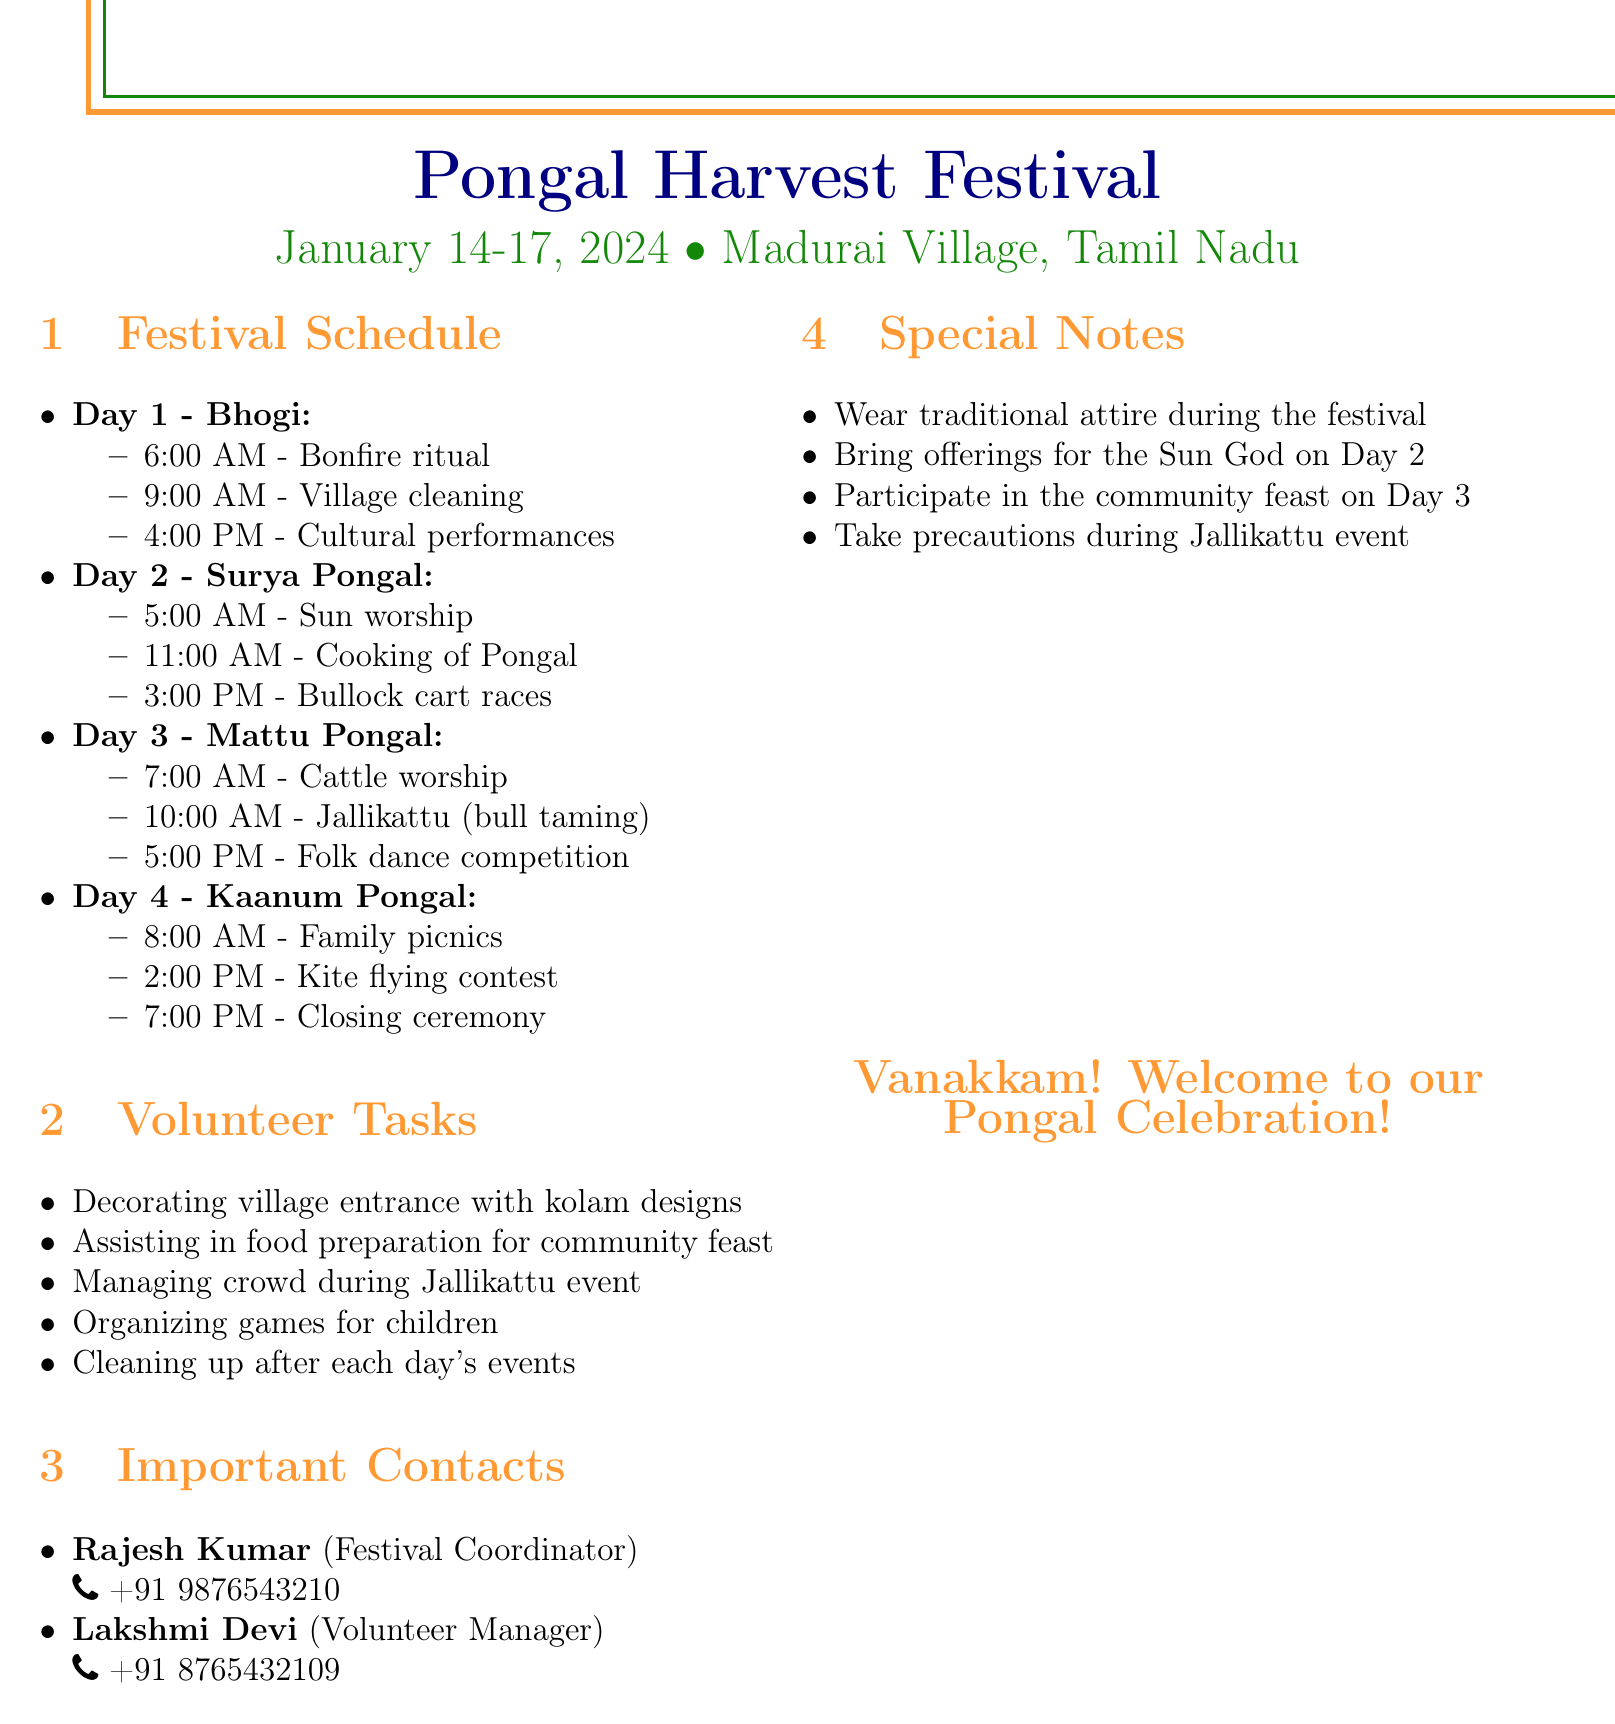What are the dates of the festival? The festival dates are explicitly mentioned at the top of the document.
Answer: January 14-17, 2024 Who is the Festival Coordinator? The document lists important contacts and their roles in a specific section.
Answer: Rajesh Kumar What is the first event on Day 1? The schedule outlines each day's events starting from the first one listed.
Answer: Bonfire ritual How many days does the festival last? The document provides the start and end dates, and the duration can be deduced from them.
Answer: 4 days What task involves food preparation? One of the volunteer tasks specifically mentions preparations related to food.
Answer: Assisting in food preparation for community feast What is one of the events planned for Day 3? The schedule specifies events for Day 3, among which any listed one can be selected.
Answer: Jallikattu (bull taming) What item should be brought on Day 2? The special notes section provides specific reminders for attendees on Day 2.
Answer: Offerings for the Sun God What time does the kite flying contest start on Day 4? The detailed schedule lists all events by time on Day 4, including the kite contest.
Answer: 2:00 PM 